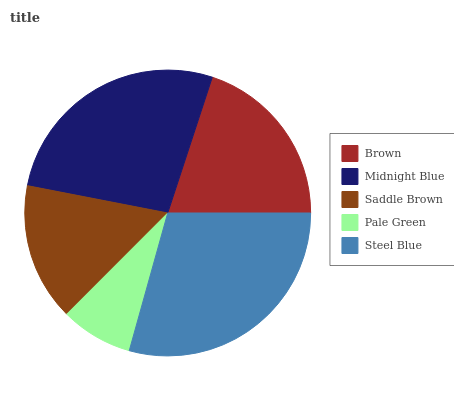Is Pale Green the minimum?
Answer yes or no. Yes. Is Steel Blue the maximum?
Answer yes or no. Yes. Is Midnight Blue the minimum?
Answer yes or no. No. Is Midnight Blue the maximum?
Answer yes or no. No. Is Midnight Blue greater than Brown?
Answer yes or no. Yes. Is Brown less than Midnight Blue?
Answer yes or no. Yes. Is Brown greater than Midnight Blue?
Answer yes or no. No. Is Midnight Blue less than Brown?
Answer yes or no. No. Is Brown the high median?
Answer yes or no. Yes. Is Brown the low median?
Answer yes or no. Yes. Is Midnight Blue the high median?
Answer yes or no. No. Is Pale Green the low median?
Answer yes or no. No. 